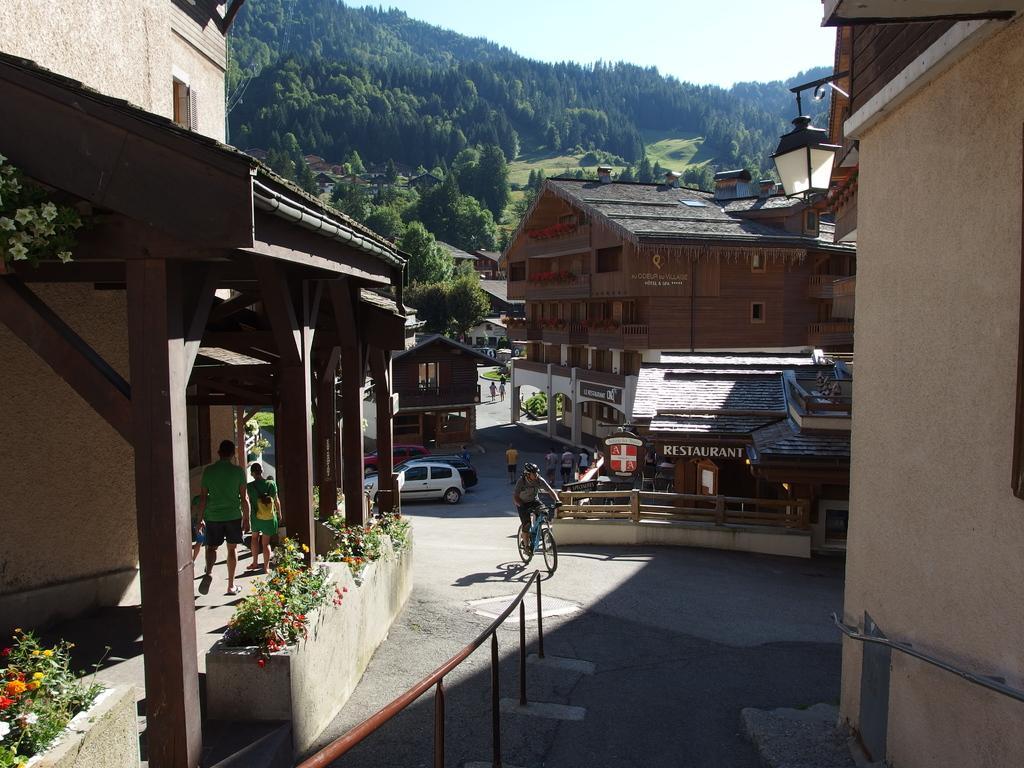Please provide a concise description of this image. In the center of the image we can see the buildings, boards, pillars, some vehicles and persons. On the right side of the image we can see a light and wall. On the left side of the image we can see the plants and flowers. At the bottom of the image we can see the road and barricade. In the background of the image we can see the hills, trees and grass. At the top of the image we can see the sky. 